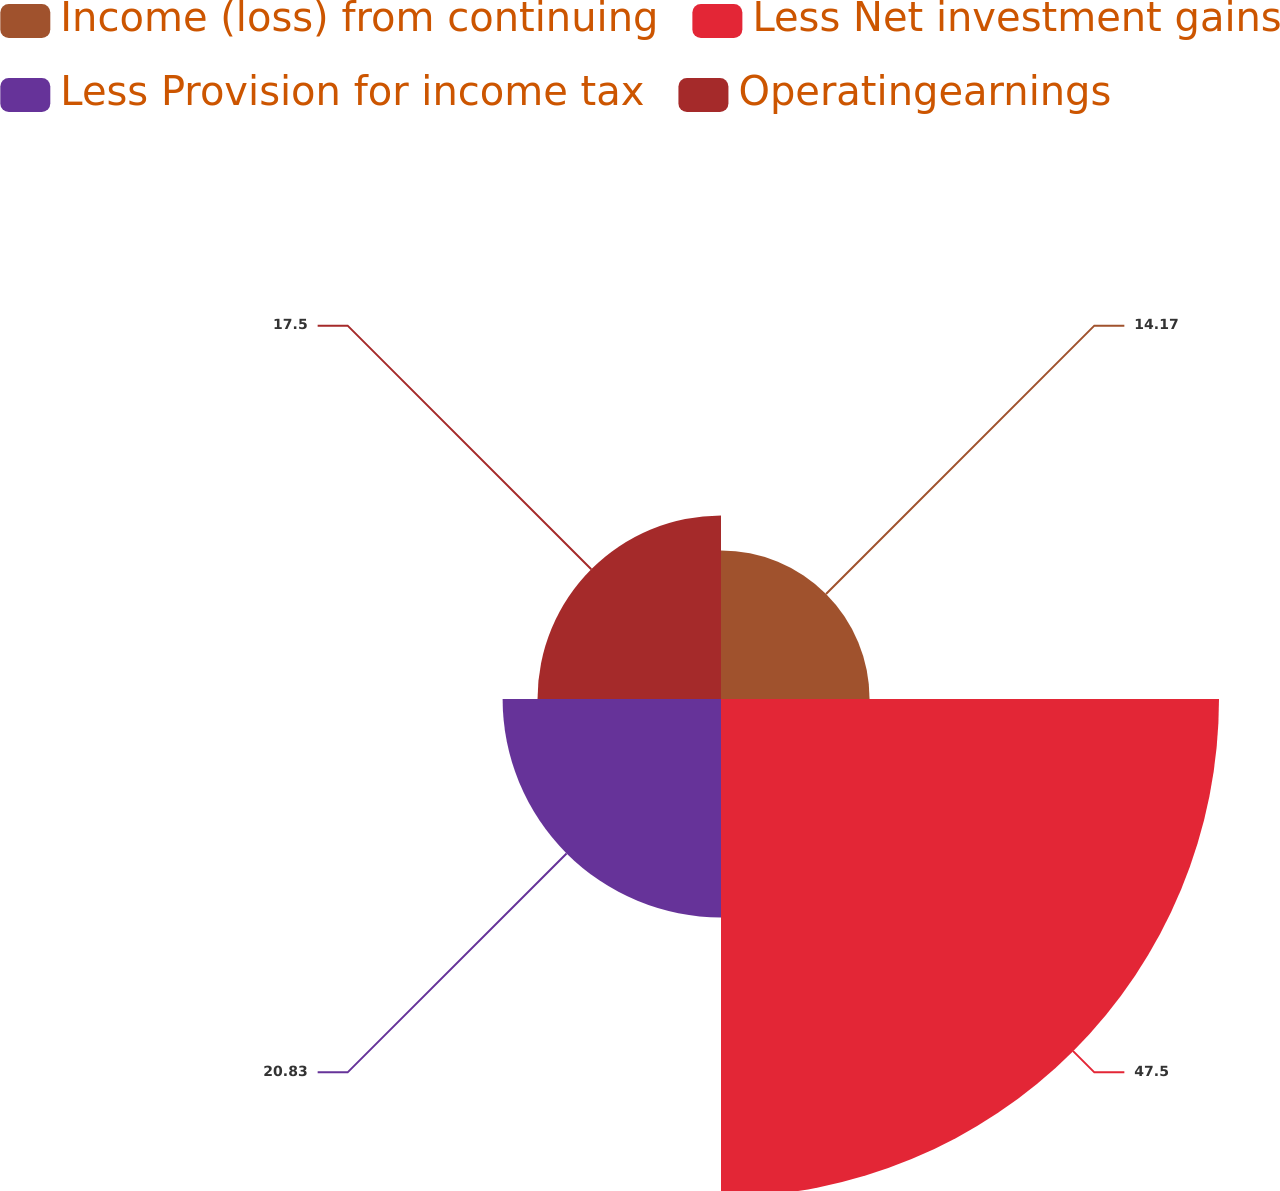Convert chart. <chart><loc_0><loc_0><loc_500><loc_500><pie_chart><fcel>Income (loss) from continuing<fcel>Less Net investment gains<fcel>Less Provision for income tax<fcel>Operatingearnings<nl><fcel>14.17%<fcel>47.5%<fcel>20.83%<fcel>17.5%<nl></chart> 